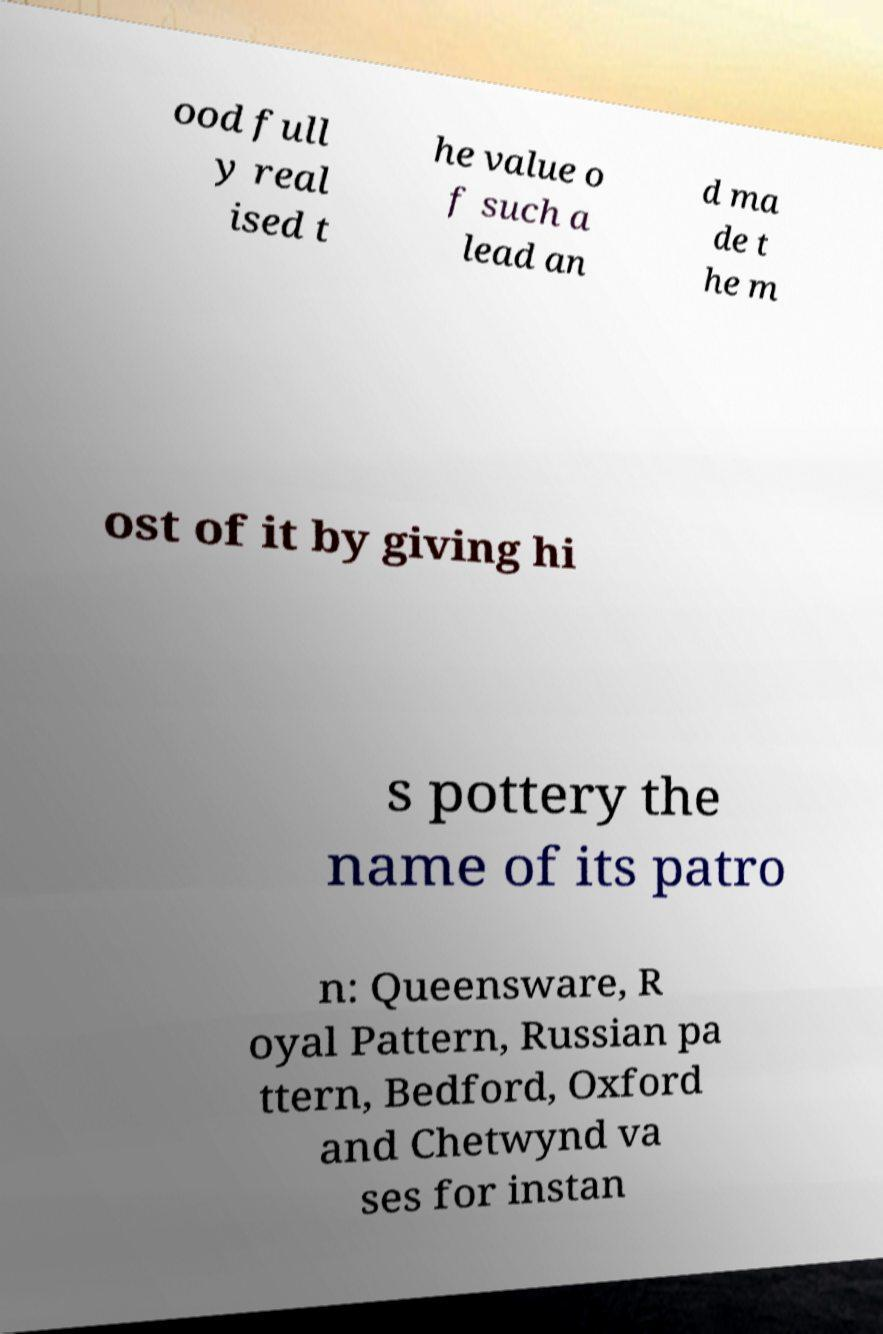Can you accurately transcribe the text from the provided image for me? ood full y real ised t he value o f such a lead an d ma de t he m ost of it by giving hi s pottery the name of its patro n: Queensware, R oyal Pattern, Russian pa ttern, Bedford, Oxford and Chetwynd va ses for instan 